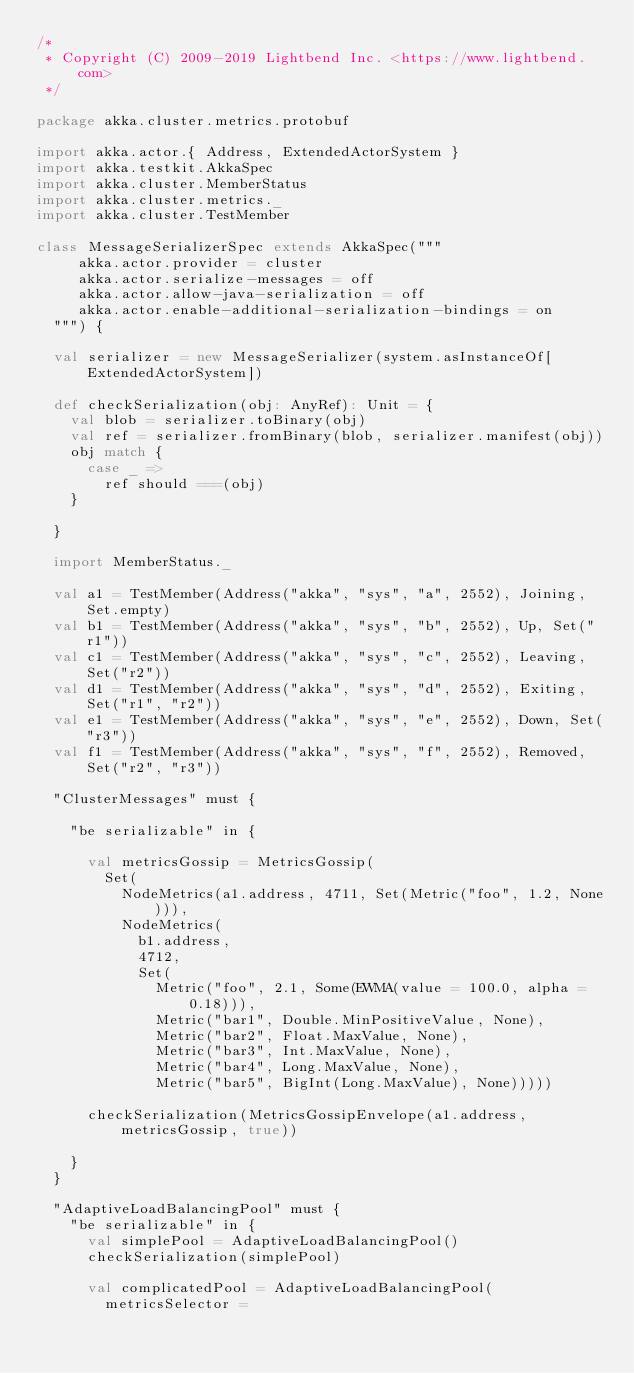Convert code to text. <code><loc_0><loc_0><loc_500><loc_500><_Scala_>/*
 * Copyright (C) 2009-2019 Lightbend Inc. <https://www.lightbend.com>
 */

package akka.cluster.metrics.protobuf

import akka.actor.{ Address, ExtendedActorSystem }
import akka.testkit.AkkaSpec
import akka.cluster.MemberStatus
import akka.cluster.metrics._
import akka.cluster.TestMember

class MessageSerializerSpec extends AkkaSpec("""
     akka.actor.provider = cluster
     akka.actor.serialize-messages = off
     akka.actor.allow-java-serialization = off
     akka.actor.enable-additional-serialization-bindings = on
  """) {

  val serializer = new MessageSerializer(system.asInstanceOf[ExtendedActorSystem])

  def checkSerialization(obj: AnyRef): Unit = {
    val blob = serializer.toBinary(obj)
    val ref = serializer.fromBinary(blob, serializer.manifest(obj))
    obj match {
      case _ =>
        ref should ===(obj)
    }

  }

  import MemberStatus._

  val a1 = TestMember(Address("akka", "sys", "a", 2552), Joining, Set.empty)
  val b1 = TestMember(Address("akka", "sys", "b", 2552), Up, Set("r1"))
  val c1 = TestMember(Address("akka", "sys", "c", 2552), Leaving, Set("r2"))
  val d1 = TestMember(Address("akka", "sys", "d", 2552), Exiting, Set("r1", "r2"))
  val e1 = TestMember(Address("akka", "sys", "e", 2552), Down, Set("r3"))
  val f1 = TestMember(Address("akka", "sys", "f", 2552), Removed, Set("r2", "r3"))

  "ClusterMessages" must {

    "be serializable" in {

      val metricsGossip = MetricsGossip(
        Set(
          NodeMetrics(a1.address, 4711, Set(Metric("foo", 1.2, None))),
          NodeMetrics(
            b1.address,
            4712,
            Set(
              Metric("foo", 2.1, Some(EWMA(value = 100.0, alpha = 0.18))),
              Metric("bar1", Double.MinPositiveValue, None),
              Metric("bar2", Float.MaxValue, None),
              Metric("bar3", Int.MaxValue, None),
              Metric("bar4", Long.MaxValue, None),
              Metric("bar5", BigInt(Long.MaxValue), None)))))

      checkSerialization(MetricsGossipEnvelope(a1.address, metricsGossip, true))

    }
  }

  "AdaptiveLoadBalancingPool" must {
    "be serializable" in {
      val simplePool = AdaptiveLoadBalancingPool()
      checkSerialization(simplePool)

      val complicatedPool = AdaptiveLoadBalancingPool(
        metricsSelector =</code> 